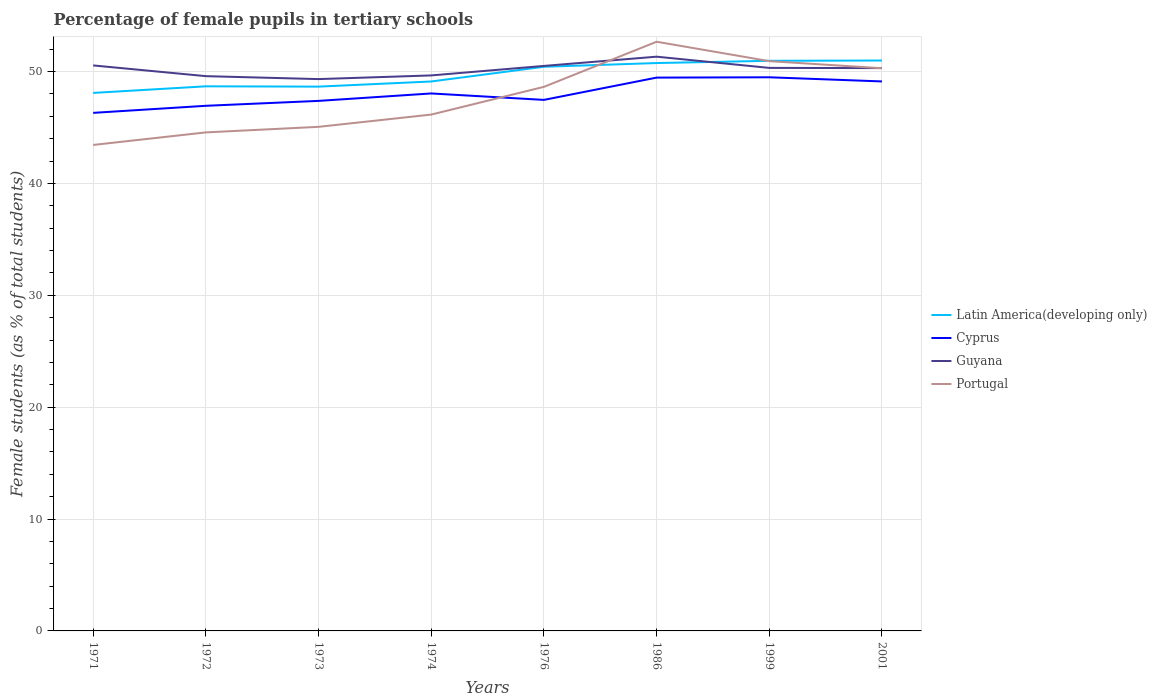Does the line corresponding to Portugal intersect with the line corresponding to Cyprus?
Ensure brevity in your answer.  Yes. Is the number of lines equal to the number of legend labels?
Your answer should be very brief. Yes. Across all years, what is the maximum percentage of female pupils in tertiary schools in Latin America(developing only)?
Your answer should be very brief. 48.09. In which year was the percentage of female pupils in tertiary schools in Cyprus maximum?
Keep it short and to the point. 1971. What is the total percentage of female pupils in tertiary schools in Cyprus in the graph?
Your answer should be compact. -2.08. What is the difference between the highest and the second highest percentage of female pupils in tertiary schools in Latin America(developing only)?
Your answer should be very brief. 2.9. How many lines are there?
Give a very brief answer. 4. Are the values on the major ticks of Y-axis written in scientific E-notation?
Give a very brief answer. No. Does the graph contain any zero values?
Your answer should be very brief. No. Does the graph contain grids?
Your answer should be compact. Yes. Where does the legend appear in the graph?
Offer a very short reply. Center right. How are the legend labels stacked?
Ensure brevity in your answer.  Vertical. What is the title of the graph?
Your answer should be very brief. Percentage of female pupils in tertiary schools. What is the label or title of the X-axis?
Keep it short and to the point. Years. What is the label or title of the Y-axis?
Your answer should be compact. Female students (as % of total students). What is the Female students (as % of total students) in Latin America(developing only) in 1971?
Offer a terse response. 48.09. What is the Female students (as % of total students) of Cyprus in 1971?
Provide a succinct answer. 46.31. What is the Female students (as % of total students) in Guyana in 1971?
Offer a very short reply. 50.55. What is the Female students (as % of total students) of Portugal in 1971?
Your answer should be very brief. 43.44. What is the Female students (as % of total students) in Latin America(developing only) in 1972?
Offer a terse response. 48.68. What is the Female students (as % of total students) of Cyprus in 1972?
Offer a very short reply. 46.94. What is the Female students (as % of total students) in Guyana in 1972?
Your response must be concise. 49.59. What is the Female students (as % of total students) of Portugal in 1972?
Give a very brief answer. 44.56. What is the Female students (as % of total students) in Latin America(developing only) in 1973?
Your response must be concise. 48.65. What is the Female students (as % of total students) of Cyprus in 1973?
Give a very brief answer. 47.38. What is the Female students (as % of total students) of Guyana in 1973?
Ensure brevity in your answer.  49.32. What is the Female students (as % of total students) of Portugal in 1973?
Ensure brevity in your answer.  45.06. What is the Female students (as % of total students) of Latin America(developing only) in 1974?
Make the answer very short. 49.11. What is the Female students (as % of total students) of Cyprus in 1974?
Offer a very short reply. 48.04. What is the Female students (as % of total students) in Guyana in 1974?
Give a very brief answer. 49.65. What is the Female students (as % of total students) in Portugal in 1974?
Provide a short and direct response. 46.15. What is the Female students (as % of total students) in Latin America(developing only) in 1976?
Make the answer very short. 50.43. What is the Female students (as % of total students) of Cyprus in 1976?
Your response must be concise. 47.47. What is the Female students (as % of total students) in Guyana in 1976?
Make the answer very short. 50.5. What is the Female students (as % of total students) of Portugal in 1976?
Your answer should be very brief. 48.63. What is the Female students (as % of total students) of Latin America(developing only) in 1986?
Give a very brief answer. 50.76. What is the Female students (as % of total students) of Cyprus in 1986?
Your response must be concise. 49.46. What is the Female students (as % of total students) of Guyana in 1986?
Your response must be concise. 51.33. What is the Female students (as % of total students) of Portugal in 1986?
Ensure brevity in your answer.  52.66. What is the Female students (as % of total students) in Latin America(developing only) in 1999?
Your answer should be very brief. 50.96. What is the Female students (as % of total students) of Cyprus in 1999?
Your response must be concise. 49.49. What is the Female students (as % of total students) of Guyana in 1999?
Offer a very short reply. 50.32. What is the Female students (as % of total students) in Portugal in 1999?
Your answer should be compact. 50.93. What is the Female students (as % of total students) in Latin America(developing only) in 2001?
Your response must be concise. 50.98. What is the Female students (as % of total students) in Cyprus in 2001?
Your response must be concise. 49.11. What is the Female students (as % of total students) in Guyana in 2001?
Keep it short and to the point. 50.31. What is the Female students (as % of total students) in Portugal in 2001?
Ensure brevity in your answer.  50.29. Across all years, what is the maximum Female students (as % of total students) in Latin America(developing only)?
Provide a short and direct response. 50.98. Across all years, what is the maximum Female students (as % of total students) in Cyprus?
Provide a succinct answer. 49.49. Across all years, what is the maximum Female students (as % of total students) in Guyana?
Offer a very short reply. 51.33. Across all years, what is the maximum Female students (as % of total students) of Portugal?
Ensure brevity in your answer.  52.66. Across all years, what is the minimum Female students (as % of total students) in Latin America(developing only)?
Your answer should be very brief. 48.09. Across all years, what is the minimum Female students (as % of total students) of Cyprus?
Offer a terse response. 46.31. Across all years, what is the minimum Female students (as % of total students) in Guyana?
Provide a short and direct response. 49.32. Across all years, what is the minimum Female students (as % of total students) of Portugal?
Offer a very short reply. 43.44. What is the total Female students (as % of total students) of Latin America(developing only) in the graph?
Give a very brief answer. 397.66. What is the total Female students (as % of total students) of Cyprus in the graph?
Make the answer very short. 384.18. What is the total Female students (as % of total students) of Guyana in the graph?
Offer a very short reply. 401.57. What is the total Female students (as % of total students) of Portugal in the graph?
Ensure brevity in your answer.  381.72. What is the difference between the Female students (as % of total students) in Latin America(developing only) in 1971 and that in 1972?
Offer a very short reply. -0.59. What is the difference between the Female students (as % of total students) in Cyprus in 1971 and that in 1972?
Ensure brevity in your answer.  -0.63. What is the difference between the Female students (as % of total students) of Portugal in 1971 and that in 1972?
Your answer should be compact. -1.12. What is the difference between the Female students (as % of total students) in Latin America(developing only) in 1971 and that in 1973?
Make the answer very short. -0.56. What is the difference between the Female students (as % of total students) of Cyprus in 1971 and that in 1973?
Offer a very short reply. -1.07. What is the difference between the Female students (as % of total students) of Guyana in 1971 and that in 1973?
Ensure brevity in your answer.  1.22. What is the difference between the Female students (as % of total students) of Portugal in 1971 and that in 1973?
Ensure brevity in your answer.  -1.62. What is the difference between the Female students (as % of total students) of Latin America(developing only) in 1971 and that in 1974?
Offer a terse response. -1.02. What is the difference between the Female students (as % of total students) of Cyprus in 1971 and that in 1974?
Make the answer very short. -1.73. What is the difference between the Female students (as % of total students) of Guyana in 1971 and that in 1974?
Provide a short and direct response. 0.89. What is the difference between the Female students (as % of total students) of Portugal in 1971 and that in 1974?
Keep it short and to the point. -2.71. What is the difference between the Female students (as % of total students) in Latin America(developing only) in 1971 and that in 1976?
Your answer should be very brief. -2.34. What is the difference between the Female students (as % of total students) in Cyprus in 1971 and that in 1976?
Keep it short and to the point. -1.16. What is the difference between the Female students (as % of total students) in Guyana in 1971 and that in 1976?
Keep it short and to the point. 0.04. What is the difference between the Female students (as % of total students) in Portugal in 1971 and that in 1976?
Keep it short and to the point. -5.19. What is the difference between the Female students (as % of total students) of Latin America(developing only) in 1971 and that in 1986?
Your answer should be very brief. -2.67. What is the difference between the Female students (as % of total students) in Cyprus in 1971 and that in 1986?
Offer a very short reply. -3.15. What is the difference between the Female students (as % of total students) in Guyana in 1971 and that in 1986?
Provide a short and direct response. -0.78. What is the difference between the Female students (as % of total students) of Portugal in 1971 and that in 1986?
Your answer should be compact. -9.23. What is the difference between the Female students (as % of total students) in Latin America(developing only) in 1971 and that in 1999?
Give a very brief answer. -2.87. What is the difference between the Female students (as % of total students) of Cyprus in 1971 and that in 1999?
Keep it short and to the point. -3.18. What is the difference between the Female students (as % of total students) of Guyana in 1971 and that in 1999?
Ensure brevity in your answer.  0.22. What is the difference between the Female students (as % of total students) in Portugal in 1971 and that in 1999?
Keep it short and to the point. -7.49. What is the difference between the Female students (as % of total students) of Latin America(developing only) in 1971 and that in 2001?
Keep it short and to the point. -2.9. What is the difference between the Female students (as % of total students) in Cyprus in 1971 and that in 2001?
Your answer should be very brief. -2.81. What is the difference between the Female students (as % of total students) of Guyana in 1971 and that in 2001?
Your answer should be compact. 0.24. What is the difference between the Female students (as % of total students) in Portugal in 1971 and that in 2001?
Your answer should be very brief. -6.86. What is the difference between the Female students (as % of total students) in Latin America(developing only) in 1972 and that in 1973?
Offer a terse response. 0.03. What is the difference between the Female students (as % of total students) in Cyprus in 1972 and that in 1973?
Give a very brief answer. -0.44. What is the difference between the Female students (as % of total students) in Guyana in 1972 and that in 1973?
Give a very brief answer. 0.26. What is the difference between the Female students (as % of total students) in Portugal in 1972 and that in 1973?
Provide a short and direct response. -0.5. What is the difference between the Female students (as % of total students) in Latin America(developing only) in 1972 and that in 1974?
Offer a terse response. -0.43. What is the difference between the Female students (as % of total students) of Cyprus in 1972 and that in 1974?
Provide a succinct answer. -1.1. What is the difference between the Female students (as % of total students) in Guyana in 1972 and that in 1974?
Your answer should be very brief. -0.07. What is the difference between the Female students (as % of total students) of Portugal in 1972 and that in 1974?
Your answer should be compact. -1.59. What is the difference between the Female students (as % of total students) in Latin America(developing only) in 1972 and that in 1976?
Your answer should be very brief. -1.75. What is the difference between the Female students (as % of total students) in Cyprus in 1972 and that in 1976?
Ensure brevity in your answer.  -0.53. What is the difference between the Female students (as % of total students) of Guyana in 1972 and that in 1976?
Provide a succinct answer. -0.91. What is the difference between the Female students (as % of total students) in Portugal in 1972 and that in 1976?
Your answer should be compact. -4.07. What is the difference between the Female students (as % of total students) of Latin America(developing only) in 1972 and that in 1986?
Give a very brief answer. -2.08. What is the difference between the Female students (as % of total students) in Cyprus in 1972 and that in 1986?
Your answer should be compact. -2.52. What is the difference between the Female students (as % of total students) of Guyana in 1972 and that in 1986?
Offer a terse response. -1.74. What is the difference between the Female students (as % of total students) of Portugal in 1972 and that in 1986?
Your answer should be compact. -8.1. What is the difference between the Female students (as % of total students) of Latin America(developing only) in 1972 and that in 1999?
Offer a very short reply. -2.28. What is the difference between the Female students (as % of total students) in Cyprus in 1972 and that in 1999?
Give a very brief answer. -2.55. What is the difference between the Female students (as % of total students) in Guyana in 1972 and that in 1999?
Provide a succinct answer. -0.74. What is the difference between the Female students (as % of total students) of Portugal in 1972 and that in 1999?
Ensure brevity in your answer.  -6.37. What is the difference between the Female students (as % of total students) of Latin America(developing only) in 1972 and that in 2001?
Ensure brevity in your answer.  -2.31. What is the difference between the Female students (as % of total students) in Cyprus in 1972 and that in 2001?
Provide a succinct answer. -2.18. What is the difference between the Female students (as % of total students) of Guyana in 1972 and that in 2001?
Provide a succinct answer. -0.72. What is the difference between the Female students (as % of total students) in Portugal in 1972 and that in 2001?
Keep it short and to the point. -5.73. What is the difference between the Female students (as % of total students) of Latin America(developing only) in 1973 and that in 1974?
Make the answer very short. -0.46. What is the difference between the Female students (as % of total students) of Cyprus in 1973 and that in 1974?
Your response must be concise. -0.67. What is the difference between the Female students (as % of total students) of Guyana in 1973 and that in 1974?
Make the answer very short. -0.33. What is the difference between the Female students (as % of total students) of Portugal in 1973 and that in 1974?
Provide a succinct answer. -1.1. What is the difference between the Female students (as % of total students) of Latin America(developing only) in 1973 and that in 1976?
Your answer should be compact. -1.78. What is the difference between the Female students (as % of total students) of Cyprus in 1973 and that in 1976?
Make the answer very short. -0.09. What is the difference between the Female students (as % of total students) in Guyana in 1973 and that in 1976?
Give a very brief answer. -1.18. What is the difference between the Female students (as % of total students) of Portugal in 1973 and that in 1976?
Give a very brief answer. -3.57. What is the difference between the Female students (as % of total students) in Latin America(developing only) in 1973 and that in 1986?
Your response must be concise. -2.11. What is the difference between the Female students (as % of total students) in Cyprus in 1973 and that in 1986?
Provide a short and direct response. -2.08. What is the difference between the Female students (as % of total students) of Guyana in 1973 and that in 1986?
Your response must be concise. -2. What is the difference between the Female students (as % of total students) of Portugal in 1973 and that in 1986?
Offer a very short reply. -7.61. What is the difference between the Female students (as % of total students) of Latin America(developing only) in 1973 and that in 1999?
Offer a terse response. -2.31. What is the difference between the Female students (as % of total students) of Cyprus in 1973 and that in 1999?
Offer a very short reply. -2.11. What is the difference between the Female students (as % of total students) of Guyana in 1973 and that in 1999?
Ensure brevity in your answer.  -1. What is the difference between the Female students (as % of total students) of Portugal in 1973 and that in 1999?
Provide a short and direct response. -5.87. What is the difference between the Female students (as % of total students) in Latin America(developing only) in 1973 and that in 2001?
Give a very brief answer. -2.33. What is the difference between the Female students (as % of total students) in Cyprus in 1973 and that in 2001?
Make the answer very short. -1.74. What is the difference between the Female students (as % of total students) in Guyana in 1973 and that in 2001?
Your answer should be compact. -0.98. What is the difference between the Female students (as % of total students) of Portugal in 1973 and that in 2001?
Ensure brevity in your answer.  -5.24. What is the difference between the Female students (as % of total students) of Latin America(developing only) in 1974 and that in 1976?
Your response must be concise. -1.32. What is the difference between the Female students (as % of total students) of Cyprus in 1974 and that in 1976?
Your answer should be compact. 0.58. What is the difference between the Female students (as % of total students) of Guyana in 1974 and that in 1976?
Provide a succinct answer. -0.85. What is the difference between the Female students (as % of total students) of Portugal in 1974 and that in 1976?
Provide a short and direct response. -2.48. What is the difference between the Female students (as % of total students) of Latin America(developing only) in 1974 and that in 1986?
Offer a terse response. -1.65. What is the difference between the Female students (as % of total students) of Cyprus in 1974 and that in 1986?
Provide a succinct answer. -1.42. What is the difference between the Female students (as % of total students) in Guyana in 1974 and that in 1986?
Make the answer very short. -1.67. What is the difference between the Female students (as % of total students) of Portugal in 1974 and that in 1986?
Offer a terse response. -6.51. What is the difference between the Female students (as % of total students) of Latin America(developing only) in 1974 and that in 1999?
Provide a short and direct response. -1.85. What is the difference between the Female students (as % of total students) of Cyprus in 1974 and that in 1999?
Offer a very short reply. -1.45. What is the difference between the Female students (as % of total students) of Guyana in 1974 and that in 1999?
Make the answer very short. -0.67. What is the difference between the Female students (as % of total students) of Portugal in 1974 and that in 1999?
Keep it short and to the point. -4.78. What is the difference between the Female students (as % of total students) of Latin America(developing only) in 1974 and that in 2001?
Ensure brevity in your answer.  -1.87. What is the difference between the Female students (as % of total students) in Cyprus in 1974 and that in 2001?
Your answer should be compact. -1.07. What is the difference between the Female students (as % of total students) in Guyana in 1974 and that in 2001?
Your answer should be compact. -0.65. What is the difference between the Female students (as % of total students) of Portugal in 1974 and that in 2001?
Provide a succinct answer. -4.14. What is the difference between the Female students (as % of total students) of Latin America(developing only) in 1976 and that in 1986?
Your response must be concise. -0.33. What is the difference between the Female students (as % of total students) in Cyprus in 1976 and that in 1986?
Your answer should be compact. -1.99. What is the difference between the Female students (as % of total students) of Guyana in 1976 and that in 1986?
Keep it short and to the point. -0.83. What is the difference between the Female students (as % of total students) in Portugal in 1976 and that in 1986?
Give a very brief answer. -4.03. What is the difference between the Female students (as % of total students) of Latin America(developing only) in 1976 and that in 1999?
Your answer should be very brief. -0.53. What is the difference between the Female students (as % of total students) of Cyprus in 1976 and that in 1999?
Your answer should be compact. -2.02. What is the difference between the Female students (as % of total students) of Guyana in 1976 and that in 1999?
Your answer should be compact. 0.18. What is the difference between the Female students (as % of total students) of Portugal in 1976 and that in 1999?
Ensure brevity in your answer.  -2.3. What is the difference between the Female students (as % of total students) of Latin America(developing only) in 1976 and that in 2001?
Provide a short and direct response. -0.56. What is the difference between the Female students (as % of total students) in Cyprus in 1976 and that in 2001?
Make the answer very short. -1.65. What is the difference between the Female students (as % of total students) of Guyana in 1976 and that in 2001?
Make the answer very short. 0.19. What is the difference between the Female students (as % of total students) of Portugal in 1976 and that in 2001?
Ensure brevity in your answer.  -1.66. What is the difference between the Female students (as % of total students) in Latin America(developing only) in 1986 and that in 1999?
Ensure brevity in your answer.  -0.2. What is the difference between the Female students (as % of total students) in Cyprus in 1986 and that in 1999?
Make the answer very short. -0.03. What is the difference between the Female students (as % of total students) in Guyana in 1986 and that in 1999?
Ensure brevity in your answer.  1. What is the difference between the Female students (as % of total students) of Portugal in 1986 and that in 1999?
Provide a short and direct response. 1.73. What is the difference between the Female students (as % of total students) in Latin America(developing only) in 1986 and that in 2001?
Provide a succinct answer. -0.23. What is the difference between the Female students (as % of total students) of Cyprus in 1986 and that in 2001?
Ensure brevity in your answer.  0.34. What is the difference between the Female students (as % of total students) in Guyana in 1986 and that in 2001?
Offer a terse response. 1.02. What is the difference between the Female students (as % of total students) in Portugal in 1986 and that in 2001?
Your answer should be compact. 2.37. What is the difference between the Female students (as % of total students) in Latin America(developing only) in 1999 and that in 2001?
Give a very brief answer. -0.03. What is the difference between the Female students (as % of total students) in Cyprus in 1999 and that in 2001?
Provide a short and direct response. 0.37. What is the difference between the Female students (as % of total students) of Guyana in 1999 and that in 2001?
Provide a short and direct response. 0.02. What is the difference between the Female students (as % of total students) in Portugal in 1999 and that in 2001?
Provide a succinct answer. 0.63. What is the difference between the Female students (as % of total students) of Latin America(developing only) in 1971 and the Female students (as % of total students) of Cyprus in 1972?
Offer a very short reply. 1.15. What is the difference between the Female students (as % of total students) of Latin America(developing only) in 1971 and the Female students (as % of total students) of Guyana in 1972?
Offer a very short reply. -1.5. What is the difference between the Female students (as % of total students) in Latin America(developing only) in 1971 and the Female students (as % of total students) in Portugal in 1972?
Keep it short and to the point. 3.53. What is the difference between the Female students (as % of total students) of Cyprus in 1971 and the Female students (as % of total students) of Guyana in 1972?
Offer a terse response. -3.28. What is the difference between the Female students (as % of total students) of Cyprus in 1971 and the Female students (as % of total students) of Portugal in 1972?
Give a very brief answer. 1.75. What is the difference between the Female students (as % of total students) in Guyana in 1971 and the Female students (as % of total students) in Portugal in 1972?
Your response must be concise. 5.99. What is the difference between the Female students (as % of total students) of Latin America(developing only) in 1971 and the Female students (as % of total students) of Cyprus in 1973?
Ensure brevity in your answer.  0.71. What is the difference between the Female students (as % of total students) of Latin America(developing only) in 1971 and the Female students (as % of total students) of Guyana in 1973?
Provide a short and direct response. -1.24. What is the difference between the Female students (as % of total students) of Latin America(developing only) in 1971 and the Female students (as % of total students) of Portugal in 1973?
Your answer should be compact. 3.03. What is the difference between the Female students (as % of total students) of Cyprus in 1971 and the Female students (as % of total students) of Guyana in 1973?
Your response must be concise. -3.02. What is the difference between the Female students (as % of total students) of Cyprus in 1971 and the Female students (as % of total students) of Portugal in 1973?
Give a very brief answer. 1.25. What is the difference between the Female students (as % of total students) in Guyana in 1971 and the Female students (as % of total students) in Portugal in 1973?
Your answer should be very brief. 5.49. What is the difference between the Female students (as % of total students) of Latin America(developing only) in 1971 and the Female students (as % of total students) of Cyprus in 1974?
Keep it short and to the point. 0.05. What is the difference between the Female students (as % of total students) in Latin America(developing only) in 1971 and the Female students (as % of total students) in Guyana in 1974?
Your response must be concise. -1.56. What is the difference between the Female students (as % of total students) of Latin America(developing only) in 1971 and the Female students (as % of total students) of Portugal in 1974?
Offer a very short reply. 1.94. What is the difference between the Female students (as % of total students) in Cyprus in 1971 and the Female students (as % of total students) in Guyana in 1974?
Offer a very short reply. -3.35. What is the difference between the Female students (as % of total students) of Cyprus in 1971 and the Female students (as % of total students) of Portugal in 1974?
Give a very brief answer. 0.15. What is the difference between the Female students (as % of total students) of Guyana in 1971 and the Female students (as % of total students) of Portugal in 1974?
Your response must be concise. 4.39. What is the difference between the Female students (as % of total students) of Latin America(developing only) in 1971 and the Female students (as % of total students) of Cyprus in 1976?
Your response must be concise. 0.62. What is the difference between the Female students (as % of total students) in Latin America(developing only) in 1971 and the Female students (as % of total students) in Guyana in 1976?
Ensure brevity in your answer.  -2.41. What is the difference between the Female students (as % of total students) in Latin America(developing only) in 1971 and the Female students (as % of total students) in Portugal in 1976?
Keep it short and to the point. -0.54. What is the difference between the Female students (as % of total students) in Cyprus in 1971 and the Female students (as % of total students) in Guyana in 1976?
Keep it short and to the point. -4.19. What is the difference between the Female students (as % of total students) of Cyprus in 1971 and the Female students (as % of total students) of Portugal in 1976?
Provide a short and direct response. -2.32. What is the difference between the Female students (as % of total students) in Guyana in 1971 and the Female students (as % of total students) in Portugal in 1976?
Keep it short and to the point. 1.92. What is the difference between the Female students (as % of total students) of Latin America(developing only) in 1971 and the Female students (as % of total students) of Cyprus in 1986?
Offer a terse response. -1.37. What is the difference between the Female students (as % of total students) of Latin America(developing only) in 1971 and the Female students (as % of total students) of Guyana in 1986?
Your answer should be very brief. -3.24. What is the difference between the Female students (as % of total students) in Latin America(developing only) in 1971 and the Female students (as % of total students) in Portugal in 1986?
Give a very brief answer. -4.57. What is the difference between the Female students (as % of total students) in Cyprus in 1971 and the Female students (as % of total students) in Guyana in 1986?
Offer a very short reply. -5.02. What is the difference between the Female students (as % of total students) of Cyprus in 1971 and the Female students (as % of total students) of Portugal in 1986?
Offer a terse response. -6.36. What is the difference between the Female students (as % of total students) of Guyana in 1971 and the Female students (as % of total students) of Portugal in 1986?
Provide a succinct answer. -2.12. What is the difference between the Female students (as % of total students) in Latin America(developing only) in 1971 and the Female students (as % of total students) in Cyprus in 1999?
Your answer should be very brief. -1.4. What is the difference between the Female students (as % of total students) in Latin America(developing only) in 1971 and the Female students (as % of total students) in Guyana in 1999?
Offer a very short reply. -2.24. What is the difference between the Female students (as % of total students) of Latin America(developing only) in 1971 and the Female students (as % of total students) of Portugal in 1999?
Your answer should be compact. -2.84. What is the difference between the Female students (as % of total students) of Cyprus in 1971 and the Female students (as % of total students) of Guyana in 1999?
Your answer should be very brief. -4.02. What is the difference between the Female students (as % of total students) of Cyprus in 1971 and the Female students (as % of total students) of Portugal in 1999?
Your answer should be very brief. -4.62. What is the difference between the Female students (as % of total students) in Guyana in 1971 and the Female students (as % of total students) in Portugal in 1999?
Your answer should be very brief. -0.38. What is the difference between the Female students (as % of total students) of Latin America(developing only) in 1971 and the Female students (as % of total students) of Cyprus in 2001?
Ensure brevity in your answer.  -1.03. What is the difference between the Female students (as % of total students) in Latin America(developing only) in 1971 and the Female students (as % of total students) in Guyana in 2001?
Offer a terse response. -2.22. What is the difference between the Female students (as % of total students) of Latin America(developing only) in 1971 and the Female students (as % of total students) of Portugal in 2001?
Ensure brevity in your answer.  -2.21. What is the difference between the Female students (as % of total students) of Cyprus in 1971 and the Female students (as % of total students) of Guyana in 2001?
Your answer should be compact. -4. What is the difference between the Female students (as % of total students) in Cyprus in 1971 and the Female students (as % of total students) in Portugal in 2001?
Give a very brief answer. -3.99. What is the difference between the Female students (as % of total students) in Guyana in 1971 and the Female students (as % of total students) in Portugal in 2001?
Offer a terse response. 0.25. What is the difference between the Female students (as % of total students) in Latin America(developing only) in 1972 and the Female students (as % of total students) in Cyprus in 1973?
Offer a terse response. 1.3. What is the difference between the Female students (as % of total students) in Latin America(developing only) in 1972 and the Female students (as % of total students) in Guyana in 1973?
Ensure brevity in your answer.  -0.65. What is the difference between the Female students (as % of total students) of Latin America(developing only) in 1972 and the Female students (as % of total students) of Portugal in 1973?
Your answer should be compact. 3.62. What is the difference between the Female students (as % of total students) in Cyprus in 1972 and the Female students (as % of total students) in Guyana in 1973?
Provide a succinct answer. -2.39. What is the difference between the Female students (as % of total students) of Cyprus in 1972 and the Female students (as % of total students) of Portugal in 1973?
Your answer should be compact. 1.88. What is the difference between the Female students (as % of total students) of Guyana in 1972 and the Female students (as % of total students) of Portugal in 1973?
Provide a short and direct response. 4.53. What is the difference between the Female students (as % of total students) in Latin America(developing only) in 1972 and the Female students (as % of total students) in Cyprus in 1974?
Your answer should be compact. 0.64. What is the difference between the Female students (as % of total students) in Latin America(developing only) in 1972 and the Female students (as % of total students) in Guyana in 1974?
Your answer should be very brief. -0.97. What is the difference between the Female students (as % of total students) of Latin America(developing only) in 1972 and the Female students (as % of total students) of Portugal in 1974?
Make the answer very short. 2.53. What is the difference between the Female students (as % of total students) in Cyprus in 1972 and the Female students (as % of total students) in Guyana in 1974?
Make the answer very short. -2.72. What is the difference between the Female students (as % of total students) of Cyprus in 1972 and the Female students (as % of total students) of Portugal in 1974?
Offer a terse response. 0.79. What is the difference between the Female students (as % of total students) in Guyana in 1972 and the Female students (as % of total students) in Portugal in 1974?
Offer a terse response. 3.44. What is the difference between the Female students (as % of total students) in Latin America(developing only) in 1972 and the Female students (as % of total students) in Cyprus in 1976?
Your response must be concise. 1.21. What is the difference between the Female students (as % of total students) of Latin America(developing only) in 1972 and the Female students (as % of total students) of Guyana in 1976?
Keep it short and to the point. -1.82. What is the difference between the Female students (as % of total students) of Latin America(developing only) in 1972 and the Female students (as % of total students) of Portugal in 1976?
Provide a short and direct response. 0.05. What is the difference between the Female students (as % of total students) of Cyprus in 1972 and the Female students (as % of total students) of Guyana in 1976?
Provide a succinct answer. -3.56. What is the difference between the Female students (as % of total students) of Cyprus in 1972 and the Female students (as % of total students) of Portugal in 1976?
Keep it short and to the point. -1.69. What is the difference between the Female students (as % of total students) of Guyana in 1972 and the Female students (as % of total students) of Portugal in 1976?
Offer a very short reply. 0.96. What is the difference between the Female students (as % of total students) in Latin America(developing only) in 1972 and the Female students (as % of total students) in Cyprus in 1986?
Provide a short and direct response. -0.78. What is the difference between the Female students (as % of total students) in Latin America(developing only) in 1972 and the Female students (as % of total students) in Guyana in 1986?
Offer a very short reply. -2.65. What is the difference between the Female students (as % of total students) of Latin America(developing only) in 1972 and the Female students (as % of total students) of Portugal in 1986?
Your response must be concise. -3.98. What is the difference between the Female students (as % of total students) in Cyprus in 1972 and the Female students (as % of total students) in Guyana in 1986?
Provide a short and direct response. -4.39. What is the difference between the Female students (as % of total students) of Cyprus in 1972 and the Female students (as % of total students) of Portugal in 1986?
Your answer should be very brief. -5.73. What is the difference between the Female students (as % of total students) in Guyana in 1972 and the Female students (as % of total students) in Portugal in 1986?
Offer a terse response. -3.08. What is the difference between the Female students (as % of total students) in Latin America(developing only) in 1972 and the Female students (as % of total students) in Cyprus in 1999?
Provide a short and direct response. -0.81. What is the difference between the Female students (as % of total students) in Latin America(developing only) in 1972 and the Female students (as % of total students) in Guyana in 1999?
Offer a very short reply. -1.65. What is the difference between the Female students (as % of total students) of Latin America(developing only) in 1972 and the Female students (as % of total students) of Portugal in 1999?
Make the answer very short. -2.25. What is the difference between the Female students (as % of total students) of Cyprus in 1972 and the Female students (as % of total students) of Guyana in 1999?
Offer a terse response. -3.39. What is the difference between the Female students (as % of total students) of Cyprus in 1972 and the Female students (as % of total students) of Portugal in 1999?
Ensure brevity in your answer.  -3.99. What is the difference between the Female students (as % of total students) in Guyana in 1972 and the Female students (as % of total students) in Portugal in 1999?
Ensure brevity in your answer.  -1.34. What is the difference between the Female students (as % of total students) in Latin America(developing only) in 1972 and the Female students (as % of total students) in Cyprus in 2001?
Your answer should be very brief. -0.44. What is the difference between the Female students (as % of total students) of Latin America(developing only) in 1972 and the Female students (as % of total students) of Guyana in 2001?
Your answer should be very brief. -1.63. What is the difference between the Female students (as % of total students) in Latin America(developing only) in 1972 and the Female students (as % of total students) in Portugal in 2001?
Your answer should be very brief. -1.62. What is the difference between the Female students (as % of total students) in Cyprus in 1972 and the Female students (as % of total students) in Guyana in 2001?
Offer a very short reply. -3.37. What is the difference between the Female students (as % of total students) of Cyprus in 1972 and the Female students (as % of total students) of Portugal in 2001?
Give a very brief answer. -3.36. What is the difference between the Female students (as % of total students) of Guyana in 1972 and the Female students (as % of total students) of Portugal in 2001?
Your answer should be compact. -0.71. What is the difference between the Female students (as % of total students) of Latin America(developing only) in 1973 and the Female students (as % of total students) of Cyprus in 1974?
Ensure brevity in your answer.  0.61. What is the difference between the Female students (as % of total students) in Latin America(developing only) in 1973 and the Female students (as % of total students) in Guyana in 1974?
Your answer should be compact. -1. What is the difference between the Female students (as % of total students) of Latin America(developing only) in 1973 and the Female students (as % of total students) of Portugal in 1974?
Ensure brevity in your answer.  2.5. What is the difference between the Female students (as % of total students) in Cyprus in 1973 and the Female students (as % of total students) in Guyana in 1974?
Offer a terse response. -2.28. What is the difference between the Female students (as % of total students) of Cyprus in 1973 and the Female students (as % of total students) of Portugal in 1974?
Offer a terse response. 1.22. What is the difference between the Female students (as % of total students) of Guyana in 1973 and the Female students (as % of total students) of Portugal in 1974?
Your response must be concise. 3.17. What is the difference between the Female students (as % of total students) in Latin America(developing only) in 1973 and the Female students (as % of total students) in Cyprus in 1976?
Your answer should be very brief. 1.19. What is the difference between the Female students (as % of total students) of Latin America(developing only) in 1973 and the Female students (as % of total students) of Guyana in 1976?
Ensure brevity in your answer.  -1.85. What is the difference between the Female students (as % of total students) of Latin America(developing only) in 1973 and the Female students (as % of total students) of Portugal in 1976?
Provide a short and direct response. 0.02. What is the difference between the Female students (as % of total students) of Cyprus in 1973 and the Female students (as % of total students) of Guyana in 1976?
Make the answer very short. -3.13. What is the difference between the Female students (as % of total students) of Cyprus in 1973 and the Female students (as % of total students) of Portugal in 1976?
Provide a short and direct response. -1.26. What is the difference between the Female students (as % of total students) in Guyana in 1973 and the Female students (as % of total students) in Portugal in 1976?
Your answer should be very brief. 0.69. What is the difference between the Female students (as % of total students) in Latin America(developing only) in 1973 and the Female students (as % of total students) in Cyprus in 1986?
Provide a short and direct response. -0.81. What is the difference between the Female students (as % of total students) in Latin America(developing only) in 1973 and the Female students (as % of total students) in Guyana in 1986?
Your response must be concise. -2.68. What is the difference between the Female students (as % of total students) in Latin America(developing only) in 1973 and the Female students (as % of total students) in Portugal in 1986?
Keep it short and to the point. -4.01. What is the difference between the Female students (as % of total students) of Cyprus in 1973 and the Female students (as % of total students) of Guyana in 1986?
Make the answer very short. -3.95. What is the difference between the Female students (as % of total students) of Cyprus in 1973 and the Female students (as % of total students) of Portugal in 1986?
Your answer should be very brief. -5.29. What is the difference between the Female students (as % of total students) in Guyana in 1973 and the Female students (as % of total students) in Portugal in 1986?
Ensure brevity in your answer.  -3.34. What is the difference between the Female students (as % of total students) in Latin America(developing only) in 1973 and the Female students (as % of total students) in Cyprus in 1999?
Your answer should be very brief. -0.84. What is the difference between the Female students (as % of total students) of Latin America(developing only) in 1973 and the Female students (as % of total students) of Guyana in 1999?
Your answer should be very brief. -1.67. What is the difference between the Female students (as % of total students) of Latin America(developing only) in 1973 and the Female students (as % of total students) of Portugal in 1999?
Your answer should be very brief. -2.28. What is the difference between the Female students (as % of total students) of Cyprus in 1973 and the Female students (as % of total students) of Guyana in 1999?
Your response must be concise. -2.95. What is the difference between the Female students (as % of total students) in Cyprus in 1973 and the Female students (as % of total students) in Portugal in 1999?
Provide a succinct answer. -3.55. What is the difference between the Female students (as % of total students) in Guyana in 1973 and the Female students (as % of total students) in Portugal in 1999?
Provide a succinct answer. -1.6. What is the difference between the Female students (as % of total students) in Latin America(developing only) in 1973 and the Female students (as % of total students) in Cyprus in 2001?
Ensure brevity in your answer.  -0.46. What is the difference between the Female students (as % of total students) in Latin America(developing only) in 1973 and the Female students (as % of total students) in Guyana in 2001?
Provide a succinct answer. -1.66. What is the difference between the Female students (as % of total students) of Latin America(developing only) in 1973 and the Female students (as % of total students) of Portugal in 2001?
Offer a terse response. -1.64. What is the difference between the Female students (as % of total students) of Cyprus in 1973 and the Female students (as % of total students) of Guyana in 2001?
Provide a succinct answer. -2.93. What is the difference between the Female students (as % of total students) in Cyprus in 1973 and the Female students (as % of total students) in Portugal in 2001?
Your response must be concise. -2.92. What is the difference between the Female students (as % of total students) in Guyana in 1973 and the Female students (as % of total students) in Portugal in 2001?
Offer a terse response. -0.97. What is the difference between the Female students (as % of total students) of Latin America(developing only) in 1974 and the Female students (as % of total students) of Cyprus in 1976?
Your answer should be compact. 1.65. What is the difference between the Female students (as % of total students) in Latin America(developing only) in 1974 and the Female students (as % of total students) in Guyana in 1976?
Provide a short and direct response. -1.39. What is the difference between the Female students (as % of total students) of Latin America(developing only) in 1974 and the Female students (as % of total students) of Portugal in 1976?
Your answer should be very brief. 0.48. What is the difference between the Female students (as % of total students) in Cyprus in 1974 and the Female students (as % of total students) in Guyana in 1976?
Make the answer very short. -2.46. What is the difference between the Female students (as % of total students) of Cyprus in 1974 and the Female students (as % of total students) of Portugal in 1976?
Your answer should be compact. -0.59. What is the difference between the Female students (as % of total students) of Guyana in 1974 and the Female students (as % of total students) of Portugal in 1976?
Offer a very short reply. 1.02. What is the difference between the Female students (as % of total students) in Latin America(developing only) in 1974 and the Female students (as % of total students) in Cyprus in 1986?
Give a very brief answer. -0.35. What is the difference between the Female students (as % of total students) in Latin America(developing only) in 1974 and the Female students (as % of total students) in Guyana in 1986?
Make the answer very short. -2.22. What is the difference between the Female students (as % of total students) in Latin America(developing only) in 1974 and the Female students (as % of total students) in Portugal in 1986?
Offer a terse response. -3.55. What is the difference between the Female students (as % of total students) in Cyprus in 1974 and the Female students (as % of total students) in Guyana in 1986?
Your response must be concise. -3.29. What is the difference between the Female students (as % of total students) of Cyprus in 1974 and the Female students (as % of total students) of Portugal in 1986?
Provide a short and direct response. -4.62. What is the difference between the Female students (as % of total students) of Guyana in 1974 and the Female students (as % of total students) of Portugal in 1986?
Give a very brief answer. -3.01. What is the difference between the Female students (as % of total students) in Latin America(developing only) in 1974 and the Female students (as % of total students) in Cyprus in 1999?
Offer a terse response. -0.38. What is the difference between the Female students (as % of total students) in Latin America(developing only) in 1974 and the Female students (as % of total students) in Guyana in 1999?
Offer a terse response. -1.21. What is the difference between the Female students (as % of total students) of Latin America(developing only) in 1974 and the Female students (as % of total students) of Portugal in 1999?
Ensure brevity in your answer.  -1.82. What is the difference between the Female students (as % of total students) in Cyprus in 1974 and the Female students (as % of total students) in Guyana in 1999?
Offer a terse response. -2.28. What is the difference between the Female students (as % of total students) of Cyprus in 1974 and the Female students (as % of total students) of Portugal in 1999?
Your response must be concise. -2.89. What is the difference between the Female students (as % of total students) of Guyana in 1974 and the Female students (as % of total students) of Portugal in 1999?
Your answer should be very brief. -1.28. What is the difference between the Female students (as % of total students) of Latin America(developing only) in 1974 and the Female students (as % of total students) of Cyprus in 2001?
Your answer should be very brief. -0. What is the difference between the Female students (as % of total students) of Latin America(developing only) in 1974 and the Female students (as % of total students) of Guyana in 2001?
Give a very brief answer. -1.2. What is the difference between the Female students (as % of total students) of Latin America(developing only) in 1974 and the Female students (as % of total students) of Portugal in 2001?
Your response must be concise. -1.18. What is the difference between the Female students (as % of total students) of Cyprus in 1974 and the Female students (as % of total students) of Guyana in 2001?
Provide a succinct answer. -2.27. What is the difference between the Female students (as % of total students) of Cyprus in 1974 and the Female students (as % of total students) of Portugal in 2001?
Make the answer very short. -2.25. What is the difference between the Female students (as % of total students) in Guyana in 1974 and the Female students (as % of total students) in Portugal in 2001?
Give a very brief answer. -0.64. What is the difference between the Female students (as % of total students) of Latin America(developing only) in 1976 and the Female students (as % of total students) of Cyprus in 1986?
Offer a very short reply. 0.97. What is the difference between the Female students (as % of total students) of Latin America(developing only) in 1976 and the Female students (as % of total students) of Guyana in 1986?
Your response must be concise. -0.9. What is the difference between the Female students (as % of total students) in Latin America(developing only) in 1976 and the Female students (as % of total students) in Portugal in 1986?
Your answer should be compact. -2.24. What is the difference between the Female students (as % of total students) of Cyprus in 1976 and the Female students (as % of total students) of Guyana in 1986?
Provide a succinct answer. -3.86. What is the difference between the Female students (as % of total students) in Cyprus in 1976 and the Female students (as % of total students) in Portugal in 1986?
Give a very brief answer. -5.2. What is the difference between the Female students (as % of total students) in Guyana in 1976 and the Female students (as % of total students) in Portugal in 1986?
Your answer should be compact. -2.16. What is the difference between the Female students (as % of total students) in Latin America(developing only) in 1976 and the Female students (as % of total students) in Cyprus in 1999?
Offer a terse response. 0.94. What is the difference between the Female students (as % of total students) of Latin America(developing only) in 1976 and the Female students (as % of total students) of Guyana in 1999?
Offer a terse response. 0.1. What is the difference between the Female students (as % of total students) in Latin America(developing only) in 1976 and the Female students (as % of total students) in Portugal in 1999?
Keep it short and to the point. -0.5. What is the difference between the Female students (as % of total students) of Cyprus in 1976 and the Female students (as % of total students) of Guyana in 1999?
Your response must be concise. -2.86. What is the difference between the Female students (as % of total students) in Cyprus in 1976 and the Female students (as % of total students) in Portugal in 1999?
Offer a terse response. -3.46. What is the difference between the Female students (as % of total students) of Guyana in 1976 and the Female students (as % of total students) of Portugal in 1999?
Offer a terse response. -0.43. What is the difference between the Female students (as % of total students) of Latin America(developing only) in 1976 and the Female students (as % of total students) of Cyprus in 2001?
Give a very brief answer. 1.31. What is the difference between the Female students (as % of total students) of Latin America(developing only) in 1976 and the Female students (as % of total students) of Guyana in 2001?
Your answer should be compact. 0.12. What is the difference between the Female students (as % of total students) in Latin America(developing only) in 1976 and the Female students (as % of total students) in Portugal in 2001?
Offer a terse response. 0.13. What is the difference between the Female students (as % of total students) of Cyprus in 1976 and the Female students (as % of total students) of Guyana in 2001?
Give a very brief answer. -2.84. What is the difference between the Female students (as % of total students) in Cyprus in 1976 and the Female students (as % of total students) in Portugal in 2001?
Ensure brevity in your answer.  -2.83. What is the difference between the Female students (as % of total students) in Guyana in 1976 and the Female students (as % of total students) in Portugal in 2001?
Your response must be concise. 0.21. What is the difference between the Female students (as % of total students) in Latin America(developing only) in 1986 and the Female students (as % of total students) in Cyprus in 1999?
Keep it short and to the point. 1.27. What is the difference between the Female students (as % of total students) of Latin America(developing only) in 1986 and the Female students (as % of total students) of Guyana in 1999?
Your answer should be very brief. 0.43. What is the difference between the Female students (as % of total students) of Latin America(developing only) in 1986 and the Female students (as % of total students) of Portugal in 1999?
Ensure brevity in your answer.  -0.17. What is the difference between the Female students (as % of total students) of Cyprus in 1986 and the Female students (as % of total students) of Guyana in 1999?
Provide a succinct answer. -0.87. What is the difference between the Female students (as % of total students) in Cyprus in 1986 and the Female students (as % of total students) in Portugal in 1999?
Ensure brevity in your answer.  -1.47. What is the difference between the Female students (as % of total students) of Guyana in 1986 and the Female students (as % of total students) of Portugal in 1999?
Your answer should be compact. 0.4. What is the difference between the Female students (as % of total students) in Latin America(developing only) in 1986 and the Female students (as % of total students) in Cyprus in 2001?
Your answer should be compact. 1.64. What is the difference between the Female students (as % of total students) in Latin America(developing only) in 1986 and the Female students (as % of total students) in Guyana in 2001?
Your answer should be very brief. 0.45. What is the difference between the Female students (as % of total students) in Latin America(developing only) in 1986 and the Female students (as % of total students) in Portugal in 2001?
Make the answer very short. 0.47. What is the difference between the Female students (as % of total students) in Cyprus in 1986 and the Female students (as % of total students) in Guyana in 2001?
Keep it short and to the point. -0.85. What is the difference between the Female students (as % of total students) of Cyprus in 1986 and the Female students (as % of total students) of Portugal in 2001?
Make the answer very short. -0.84. What is the difference between the Female students (as % of total students) in Guyana in 1986 and the Female students (as % of total students) in Portugal in 2001?
Offer a terse response. 1.03. What is the difference between the Female students (as % of total students) of Latin America(developing only) in 1999 and the Female students (as % of total students) of Cyprus in 2001?
Give a very brief answer. 1.84. What is the difference between the Female students (as % of total students) of Latin America(developing only) in 1999 and the Female students (as % of total students) of Guyana in 2001?
Ensure brevity in your answer.  0.65. What is the difference between the Female students (as % of total students) of Latin America(developing only) in 1999 and the Female students (as % of total students) of Portugal in 2001?
Your answer should be compact. 0.67. What is the difference between the Female students (as % of total students) in Cyprus in 1999 and the Female students (as % of total students) in Guyana in 2001?
Provide a succinct answer. -0.82. What is the difference between the Female students (as % of total students) in Cyprus in 1999 and the Female students (as % of total students) in Portugal in 2001?
Your response must be concise. -0.81. What is the difference between the Female students (as % of total students) of Guyana in 1999 and the Female students (as % of total students) of Portugal in 2001?
Keep it short and to the point. 0.03. What is the average Female students (as % of total students) in Latin America(developing only) per year?
Your answer should be very brief. 49.71. What is the average Female students (as % of total students) of Cyprus per year?
Offer a terse response. 48.02. What is the average Female students (as % of total students) in Guyana per year?
Your response must be concise. 50.2. What is the average Female students (as % of total students) in Portugal per year?
Offer a terse response. 47.72. In the year 1971, what is the difference between the Female students (as % of total students) of Latin America(developing only) and Female students (as % of total students) of Cyprus?
Make the answer very short. 1.78. In the year 1971, what is the difference between the Female students (as % of total students) of Latin America(developing only) and Female students (as % of total students) of Guyana?
Provide a short and direct response. -2.46. In the year 1971, what is the difference between the Female students (as % of total students) in Latin America(developing only) and Female students (as % of total students) in Portugal?
Make the answer very short. 4.65. In the year 1971, what is the difference between the Female students (as % of total students) in Cyprus and Female students (as % of total students) in Guyana?
Keep it short and to the point. -4.24. In the year 1971, what is the difference between the Female students (as % of total students) in Cyprus and Female students (as % of total students) in Portugal?
Offer a very short reply. 2.87. In the year 1971, what is the difference between the Female students (as % of total students) in Guyana and Female students (as % of total students) in Portugal?
Your answer should be compact. 7.11. In the year 1972, what is the difference between the Female students (as % of total students) in Latin America(developing only) and Female students (as % of total students) in Cyprus?
Your answer should be compact. 1.74. In the year 1972, what is the difference between the Female students (as % of total students) of Latin America(developing only) and Female students (as % of total students) of Guyana?
Your answer should be compact. -0.91. In the year 1972, what is the difference between the Female students (as % of total students) in Latin America(developing only) and Female students (as % of total students) in Portugal?
Ensure brevity in your answer.  4.12. In the year 1972, what is the difference between the Female students (as % of total students) of Cyprus and Female students (as % of total students) of Guyana?
Your answer should be very brief. -2.65. In the year 1972, what is the difference between the Female students (as % of total students) of Cyprus and Female students (as % of total students) of Portugal?
Make the answer very short. 2.38. In the year 1972, what is the difference between the Female students (as % of total students) in Guyana and Female students (as % of total students) in Portugal?
Your answer should be compact. 5.03. In the year 1973, what is the difference between the Female students (as % of total students) of Latin America(developing only) and Female students (as % of total students) of Cyprus?
Make the answer very short. 1.27. In the year 1973, what is the difference between the Female students (as % of total students) of Latin America(developing only) and Female students (as % of total students) of Guyana?
Give a very brief answer. -0.67. In the year 1973, what is the difference between the Female students (as % of total students) in Latin America(developing only) and Female students (as % of total students) in Portugal?
Make the answer very short. 3.59. In the year 1973, what is the difference between the Female students (as % of total students) of Cyprus and Female students (as % of total students) of Guyana?
Your answer should be compact. -1.95. In the year 1973, what is the difference between the Female students (as % of total students) of Cyprus and Female students (as % of total students) of Portugal?
Your answer should be compact. 2.32. In the year 1973, what is the difference between the Female students (as % of total students) of Guyana and Female students (as % of total students) of Portugal?
Provide a succinct answer. 4.27. In the year 1974, what is the difference between the Female students (as % of total students) in Latin America(developing only) and Female students (as % of total students) in Cyprus?
Provide a short and direct response. 1.07. In the year 1974, what is the difference between the Female students (as % of total students) of Latin America(developing only) and Female students (as % of total students) of Guyana?
Your response must be concise. -0.54. In the year 1974, what is the difference between the Female students (as % of total students) in Latin America(developing only) and Female students (as % of total students) in Portugal?
Ensure brevity in your answer.  2.96. In the year 1974, what is the difference between the Female students (as % of total students) of Cyprus and Female students (as % of total students) of Guyana?
Offer a very short reply. -1.61. In the year 1974, what is the difference between the Female students (as % of total students) of Cyprus and Female students (as % of total students) of Portugal?
Your answer should be very brief. 1.89. In the year 1974, what is the difference between the Female students (as % of total students) in Guyana and Female students (as % of total students) in Portugal?
Provide a succinct answer. 3.5. In the year 1976, what is the difference between the Female students (as % of total students) in Latin America(developing only) and Female students (as % of total students) in Cyprus?
Make the answer very short. 2.96. In the year 1976, what is the difference between the Female students (as % of total students) in Latin America(developing only) and Female students (as % of total students) in Guyana?
Your answer should be very brief. -0.07. In the year 1976, what is the difference between the Female students (as % of total students) in Latin America(developing only) and Female students (as % of total students) in Portugal?
Give a very brief answer. 1.8. In the year 1976, what is the difference between the Female students (as % of total students) of Cyprus and Female students (as % of total students) of Guyana?
Offer a terse response. -3.04. In the year 1976, what is the difference between the Female students (as % of total students) in Cyprus and Female students (as % of total students) in Portugal?
Make the answer very short. -1.17. In the year 1976, what is the difference between the Female students (as % of total students) of Guyana and Female students (as % of total students) of Portugal?
Provide a short and direct response. 1.87. In the year 1986, what is the difference between the Female students (as % of total students) of Latin America(developing only) and Female students (as % of total students) of Cyprus?
Keep it short and to the point. 1.3. In the year 1986, what is the difference between the Female students (as % of total students) of Latin America(developing only) and Female students (as % of total students) of Guyana?
Your response must be concise. -0.57. In the year 1986, what is the difference between the Female students (as % of total students) of Latin America(developing only) and Female students (as % of total students) of Portugal?
Provide a short and direct response. -1.9. In the year 1986, what is the difference between the Female students (as % of total students) of Cyprus and Female students (as % of total students) of Guyana?
Your response must be concise. -1.87. In the year 1986, what is the difference between the Female students (as % of total students) of Cyprus and Female students (as % of total students) of Portugal?
Your answer should be very brief. -3.21. In the year 1986, what is the difference between the Female students (as % of total students) in Guyana and Female students (as % of total students) in Portugal?
Offer a very short reply. -1.34. In the year 1999, what is the difference between the Female students (as % of total students) of Latin America(developing only) and Female students (as % of total students) of Cyprus?
Offer a very short reply. 1.47. In the year 1999, what is the difference between the Female students (as % of total students) in Latin America(developing only) and Female students (as % of total students) in Guyana?
Offer a very short reply. 0.63. In the year 1999, what is the difference between the Female students (as % of total students) in Latin America(developing only) and Female students (as % of total students) in Portugal?
Make the answer very short. 0.03. In the year 1999, what is the difference between the Female students (as % of total students) of Cyprus and Female students (as % of total students) of Guyana?
Ensure brevity in your answer.  -0.84. In the year 1999, what is the difference between the Female students (as % of total students) of Cyprus and Female students (as % of total students) of Portugal?
Offer a terse response. -1.44. In the year 1999, what is the difference between the Female students (as % of total students) of Guyana and Female students (as % of total students) of Portugal?
Your response must be concise. -0.6. In the year 2001, what is the difference between the Female students (as % of total students) of Latin America(developing only) and Female students (as % of total students) of Cyprus?
Offer a terse response. 1.87. In the year 2001, what is the difference between the Female students (as % of total students) in Latin America(developing only) and Female students (as % of total students) in Guyana?
Offer a terse response. 0.68. In the year 2001, what is the difference between the Female students (as % of total students) of Latin America(developing only) and Female students (as % of total students) of Portugal?
Your answer should be very brief. 0.69. In the year 2001, what is the difference between the Female students (as % of total students) in Cyprus and Female students (as % of total students) in Guyana?
Offer a very short reply. -1.19. In the year 2001, what is the difference between the Female students (as % of total students) of Cyprus and Female students (as % of total students) of Portugal?
Keep it short and to the point. -1.18. In the year 2001, what is the difference between the Female students (as % of total students) in Guyana and Female students (as % of total students) in Portugal?
Give a very brief answer. 0.01. What is the ratio of the Female students (as % of total students) of Latin America(developing only) in 1971 to that in 1972?
Provide a short and direct response. 0.99. What is the ratio of the Female students (as % of total students) in Cyprus in 1971 to that in 1972?
Provide a short and direct response. 0.99. What is the ratio of the Female students (as % of total students) of Guyana in 1971 to that in 1972?
Your response must be concise. 1.02. What is the ratio of the Female students (as % of total students) in Portugal in 1971 to that in 1972?
Give a very brief answer. 0.97. What is the ratio of the Female students (as % of total students) of Latin America(developing only) in 1971 to that in 1973?
Give a very brief answer. 0.99. What is the ratio of the Female students (as % of total students) in Cyprus in 1971 to that in 1973?
Provide a short and direct response. 0.98. What is the ratio of the Female students (as % of total students) of Guyana in 1971 to that in 1973?
Offer a terse response. 1.02. What is the ratio of the Female students (as % of total students) of Portugal in 1971 to that in 1973?
Provide a succinct answer. 0.96. What is the ratio of the Female students (as % of total students) in Latin America(developing only) in 1971 to that in 1974?
Make the answer very short. 0.98. What is the ratio of the Female students (as % of total students) in Cyprus in 1971 to that in 1974?
Ensure brevity in your answer.  0.96. What is the ratio of the Female students (as % of total students) in Guyana in 1971 to that in 1974?
Your response must be concise. 1.02. What is the ratio of the Female students (as % of total students) of Portugal in 1971 to that in 1974?
Your answer should be compact. 0.94. What is the ratio of the Female students (as % of total students) of Latin America(developing only) in 1971 to that in 1976?
Give a very brief answer. 0.95. What is the ratio of the Female students (as % of total students) in Cyprus in 1971 to that in 1976?
Your response must be concise. 0.98. What is the ratio of the Female students (as % of total students) in Portugal in 1971 to that in 1976?
Your response must be concise. 0.89. What is the ratio of the Female students (as % of total students) of Latin America(developing only) in 1971 to that in 1986?
Keep it short and to the point. 0.95. What is the ratio of the Female students (as % of total students) of Cyprus in 1971 to that in 1986?
Your answer should be compact. 0.94. What is the ratio of the Female students (as % of total students) in Portugal in 1971 to that in 1986?
Ensure brevity in your answer.  0.82. What is the ratio of the Female students (as % of total students) in Latin America(developing only) in 1971 to that in 1999?
Ensure brevity in your answer.  0.94. What is the ratio of the Female students (as % of total students) of Cyprus in 1971 to that in 1999?
Offer a terse response. 0.94. What is the ratio of the Female students (as % of total students) in Guyana in 1971 to that in 1999?
Your response must be concise. 1. What is the ratio of the Female students (as % of total students) in Portugal in 1971 to that in 1999?
Provide a succinct answer. 0.85. What is the ratio of the Female students (as % of total students) in Latin America(developing only) in 1971 to that in 2001?
Ensure brevity in your answer.  0.94. What is the ratio of the Female students (as % of total students) in Cyprus in 1971 to that in 2001?
Provide a succinct answer. 0.94. What is the ratio of the Female students (as % of total students) in Guyana in 1971 to that in 2001?
Offer a terse response. 1. What is the ratio of the Female students (as % of total students) in Portugal in 1971 to that in 2001?
Ensure brevity in your answer.  0.86. What is the ratio of the Female students (as % of total students) in Latin America(developing only) in 1972 to that in 1974?
Your response must be concise. 0.99. What is the ratio of the Female students (as % of total students) of Portugal in 1972 to that in 1974?
Give a very brief answer. 0.97. What is the ratio of the Female students (as % of total students) of Latin America(developing only) in 1972 to that in 1976?
Provide a succinct answer. 0.97. What is the ratio of the Female students (as % of total students) in Cyprus in 1972 to that in 1976?
Offer a terse response. 0.99. What is the ratio of the Female students (as % of total students) of Guyana in 1972 to that in 1976?
Make the answer very short. 0.98. What is the ratio of the Female students (as % of total students) in Portugal in 1972 to that in 1976?
Your response must be concise. 0.92. What is the ratio of the Female students (as % of total students) in Cyprus in 1972 to that in 1986?
Offer a very short reply. 0.95. What is the ratio of the Female students (as % of total students) in Guyana in 1972 to that in 1986?
Provide a succinct answer. 0.97. What is the ratio of the Female students (as % of total students) of Portugal in 1972 to that in 1986?
Offer a very short reply. 0.85. What is the ratio of the Female students (as % of total students) of Latin America(developing only) in 1972 to that in 1999?
Your response must be concise. 0.96. What is the ratio of the Female students (as % of total students) in Cyprus in 1972 to that in 1999?
Give a very brief answer. 0.95. What is the ratio of the Female students (as % of total students) in Guyana in 1972 to that in 1999?
Ensure brevity in your answer.  0.99. What is the ratio of the Female students (as % of total students) in Latin America(developing only) in 1972 to that in 2001?
Keep it short and to the point. 0.95. What is the ratio of the Female students (as % of total students) of Cyprus in 1972 to that in 2001?
Provide a succinct answer. 0.96. What is the ratio of the Female students (as % of total students) of Guyana in 1972 to that in 2001?
Keep it short and to the point. 0.99. What is the ratio of the Female students (as % of total students) in Portugal in 1972 to that in 2001?
Ensure brevity in your answer.  0.89. What is the ratio of the Female students (as % of total students) in Latin America(developing only) in 1973 to that in 1974?
Provide a short and direct response. 0.99. What is the ratio of the Female students (as % of total students) in Cyprus in 1973 to that in 1974?
Give a very brief answer. 0.99. What is the ratio of the Female students (as % of total students) in Guyana in 1973 to that in 1974?
Give a very brief answer. 0.99. What is the ratio of the Female students (as % of total students) in Portugal in 1973 to that in 1974?
Make the answer very short. 0.98. What is the ratio of the Female students (as % of total students) of Latin America(developing only) in 1973 to that in 1976?
Provide a short and direct response. 0.96. What is the ratio of the Female students (as % of total students) in Guyana in 1973 to that in 1976?
Provide a succinct answer. 0.98. What is the ratio of the Female students (as % of total students) in Portugal in 1973 to that in 1976?
Make the answer very short. 0.93. What is the ratio of the Female students (as % of total students) of Latin America(developing only) in 1973 to that in 1986?
Offer a terse response. 0.96. What is the ratio of the Female students (as % of total students) of Cyprus in 1973 to that in 1986?
Ensure brevity in your answer.  0.96. What is the ratio of the Female students (as % of total students) of Guyana in 1973 to that in 1986?
Give a very brief answer. 0.96. What is the ratio of the Female students (as % of total students) in Portugal in 1973 to that in 1986?
Offer a very short reply. 0.86. What is the ratio of the Female students (as % of total students) in Latin America(developing only) in 1973 to that in 1999?
Provide a short and direct response. 0.95. What is the ratio of the Female students (as % of total students) in Cyprus in 1973 to that in 1999?
Make the answer very short. 0.96. What is the ratio of the Female students (as % of total students) in Guyana in 1973 to that in 1999?
Your answer should be compact. 0.98. What is the ratio of the Female students (as % of total students) of Portugal in 1973 to that in 1999?
Your response must be concise. 0.88. What is the ratio of the Female students (as % of total students) of Latin America(developing only) in 1973 to that in 2001?
Your answer should be very brief. 0.95. What is the ratio of the Female students (as % of total students) of Cyprus in 1973 to that in 2001?
Give a very brief answer. 0.96. What is the ratio of the Female students (as % of total students) of Guyana in 1973 to that in 2001?
Provide a succinct answer. 0.98. What is the ratio of the Female students (as % of total students) in Portugal in 1973 to that in 2001?
Offer a terse response. 0.9. What is the ratio of the Female students (as % of total students) of Latin America(developing only) in 1974 to that in 1976?
Offer a terse response. 0.97. What is the ratio of the Female students (as % of total students) of Cyprus in 1974 to that in 1976?
Your answer should be very brief. 1.01. What is the ratio of the Female students (as % of total students) in Guyana in 1974 to that in 1976?
Give a very brief answer. 0.98. What is the ratio of the Female students (as % of total students) in Portugal in 1974 to that in 1976?
Ensure brevity in your answer.  0.95. What is the ratio of the Female students (as % of total students) in Latin America(developing only) in 1974 to that in 1986?
Make the answer very short. 0.97. What is the ratio of the Female students (as % of total students) in Cyprus in 1974 to that in 1986?
Keep it short and to the point. 0.97. What is the ratio of the Female students (as % of total students) of Guyana in 1974 to that in 1986?
Offer a terse response. 0.97. What is the ratio of the Female students (as % of total students) in Portugal in 1974 to that in 1986?
Make the answer very short. 0.88. What is the ratio of the Female students (as % of total students) in Latin America(developing only) in 1974 to that in 1999?
Provide a succinct answer. 0.96. What is the ratio of the Female students (as % of total students) of Cyprus in 1974 to that in 1999?
Give a very brief answer. 0.97. What is the ratio of the Female students (as % of total students) in Guyana in 1974 to that in 1999?
Provide a succinct answer. 0.99. What is the ratio of the Female students (as % of total students) of Portugal in 1974 to that in 1999?
Provide a succinct answer. 0.91. What is the ratio of the Female students (as % of total students) in Latin America(developing only) in 1974 to that in 2001?
Give a very brief answer. 0.96. What is the ratio of the Female students (as % of total students) in Cyprus in 1974 to that in 2001?
Keep it short and to the point. 0.98. What is the ratio of the Female students (as % of total students) in Portugal in 1974 to that in 2001?
Provide a succinct answer. 0.92. What is the ratio of the Female students (as % of total students) of Cyprus in 1976 to that in 1986?
Make the answer very short. 0.96. What is the ratio of the Female students (as % of total students) of Guyana in 1976 to that in 1986?
Offer a very short reply. 0.98. What is the ratio of the Female students (as % of total students) in Portugal in 1976 to that in 1986?
Offer a very short reply. 0.92. What is the ratio of the Female students (as % of total students) of Cyprus in 1976 to that in 1999?
Make the answer very short. 0.96. What is the ratio of the Female students (as % of total students) of Guyana in 1976 to that in 1999?
Keep it short and to the point. 1. What is the ratio of the Female students (as % of total students) in Portugal in 1976 to that in 1999?
Your answer should be compact. 0.95. What is the ratio of the Female students (as % of total students) of Latin America(developing only) in 1976 to that in 2001?
Offer a very short reply. 0.99. What is the ratio of the Female students (as % of total students) in Cyprus in 1976 to that in 2001?
Your response must be concise. 0.97. What is the ratio of the Female students (as % of total students) in Guyana in 1976 to that in 2001?
Make the answer very short. 1. What is the ratio of the Female students (as % of total students) in Portugal in 1976 to that in 2001?
Your answer should be compact. 0.97. What is the ratio of the Female students (as % of total students) of Cyprus in 1986 to that in 1999?
Provide a short and direct response. 1. What is the ratio of the Female students (as % of total students) of Guyana in 1986 to that in 1999?
Offer a terse response. 1.02. What is the ratio of the Female students (as % of total students) in Portugal in 1986 to that in 1999?
Provide a succinct answer. 1.03. What is the ratio of the Female students (as % of total students) of Latin America(developing only) in 1986 to that in 2001?
Provide a short and direct response. 1. What is the ratio of the Female students (as % of total students) in Cyprus in 1986 to that in 2001?
Your response must be concise. 1.01. What is the ratio of the Female students (as % of total students) in Guyana in 1986 to that in 2001?
Give a very brief answer. 1.02. What is the ratio of the Female students (as % of total students) of Portugal in 1986 to that in 2001?
Your answer should be compact. 1.05. What is the ratio of the Female students (as % of total students) in Cyprus in 1999 to that in 2001?
Keep it short and to the point. 1.01. What is the ratio of the Female students (as % of total students) of Portugal in 1999 to that in 2001?
Provide a succinct answer. 1.01. What is the difference between the highest and the second highest Female students (as % of total students) in Latin America(developing only)?
Provide a short and direct response. 0.03. What is the difference between the highest and the second highest Female students (as % of total students) in Cyprus?
Offer a terse response. 0.03. What is the difference between the highest and the second highest Female students (as % of total students) in Guyana?
Make the answer very short. 0.78. What is the difference between the highest and the second highest Female students (as % of total students) in Portugal?
Keep it short and to the point. 1.73. What is the difference between the highest and the lowest Female students (as % of total students) in Latin America(developing only)?
Your answer should be very brief. 2.9. What is the difference between the highest and the lowest Female students (as % of total students) in Cyprus?
Provide a short and direct response. 3.18. What is the difference between the highest and the lowest Female students (as % of total students) in Guyana?
Keep it short and to the point. 2. What is the difference between the highest and the lowest Female students (as % of total students) in Portugal?
Offer a terse response. 9.23. 